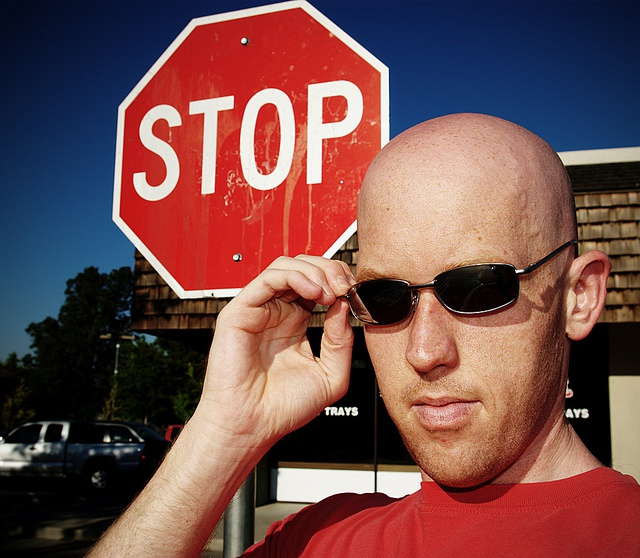Describe the objects in this image and their specific colors. I can see people in black, tan, brown, and salmon tones, stop sign in black, brown, ivory, and red tones, car in black, gray, darkgray, and lightgray tones, and car in black, maroon, and brown tones in this image. 